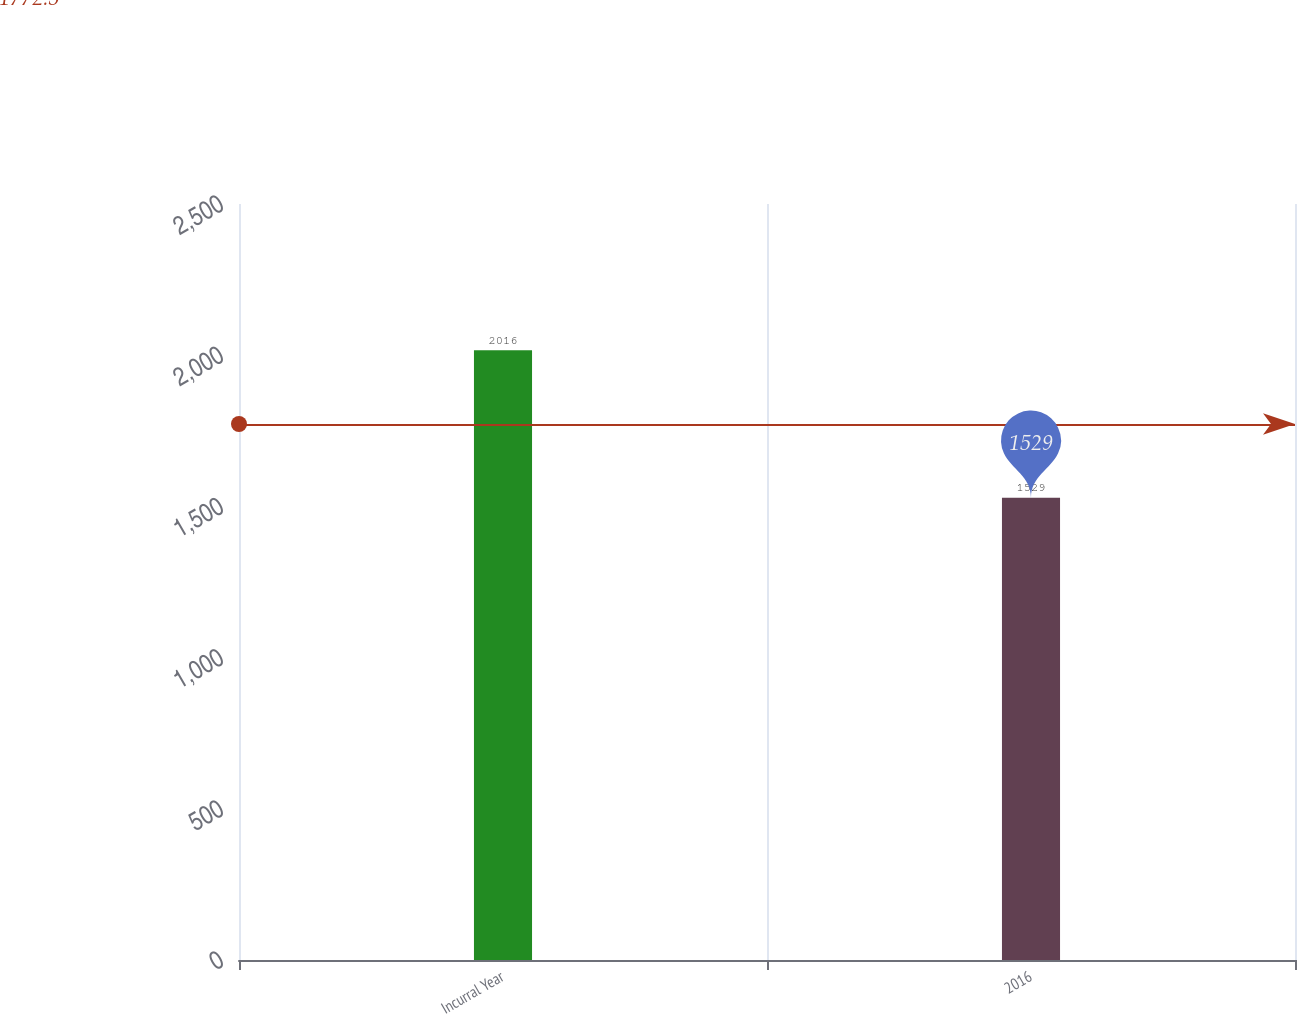Convert chart. <chart><loc_0><loc_0><loc_500><loc_500><bar_chart><fcel>Incurral Year<fcel>2016<nl><fcel>2016<fcel>1529<nl></chart> 